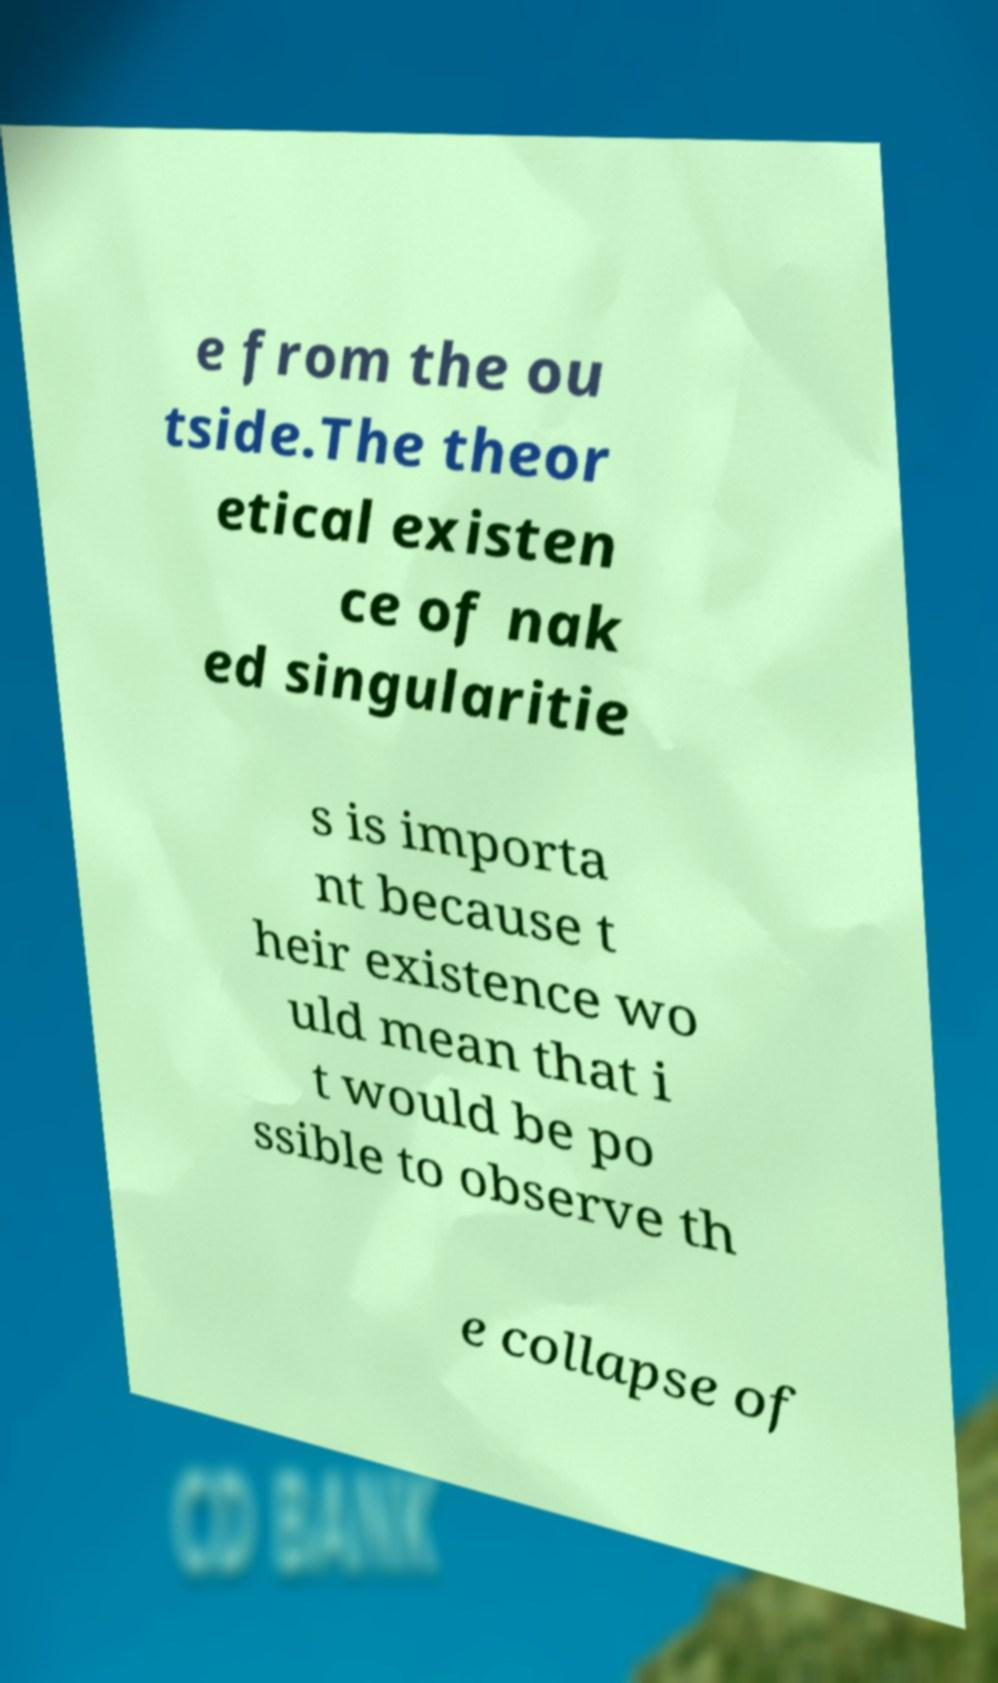What messages or text are displayed in this image? I need them in a readable, typed format. e from the ou tside.The theor etical existen ce of nak ed singularitie s is importa nt because t heir existence wo uld mean that i t would be po ssible to observe th e collapse of 